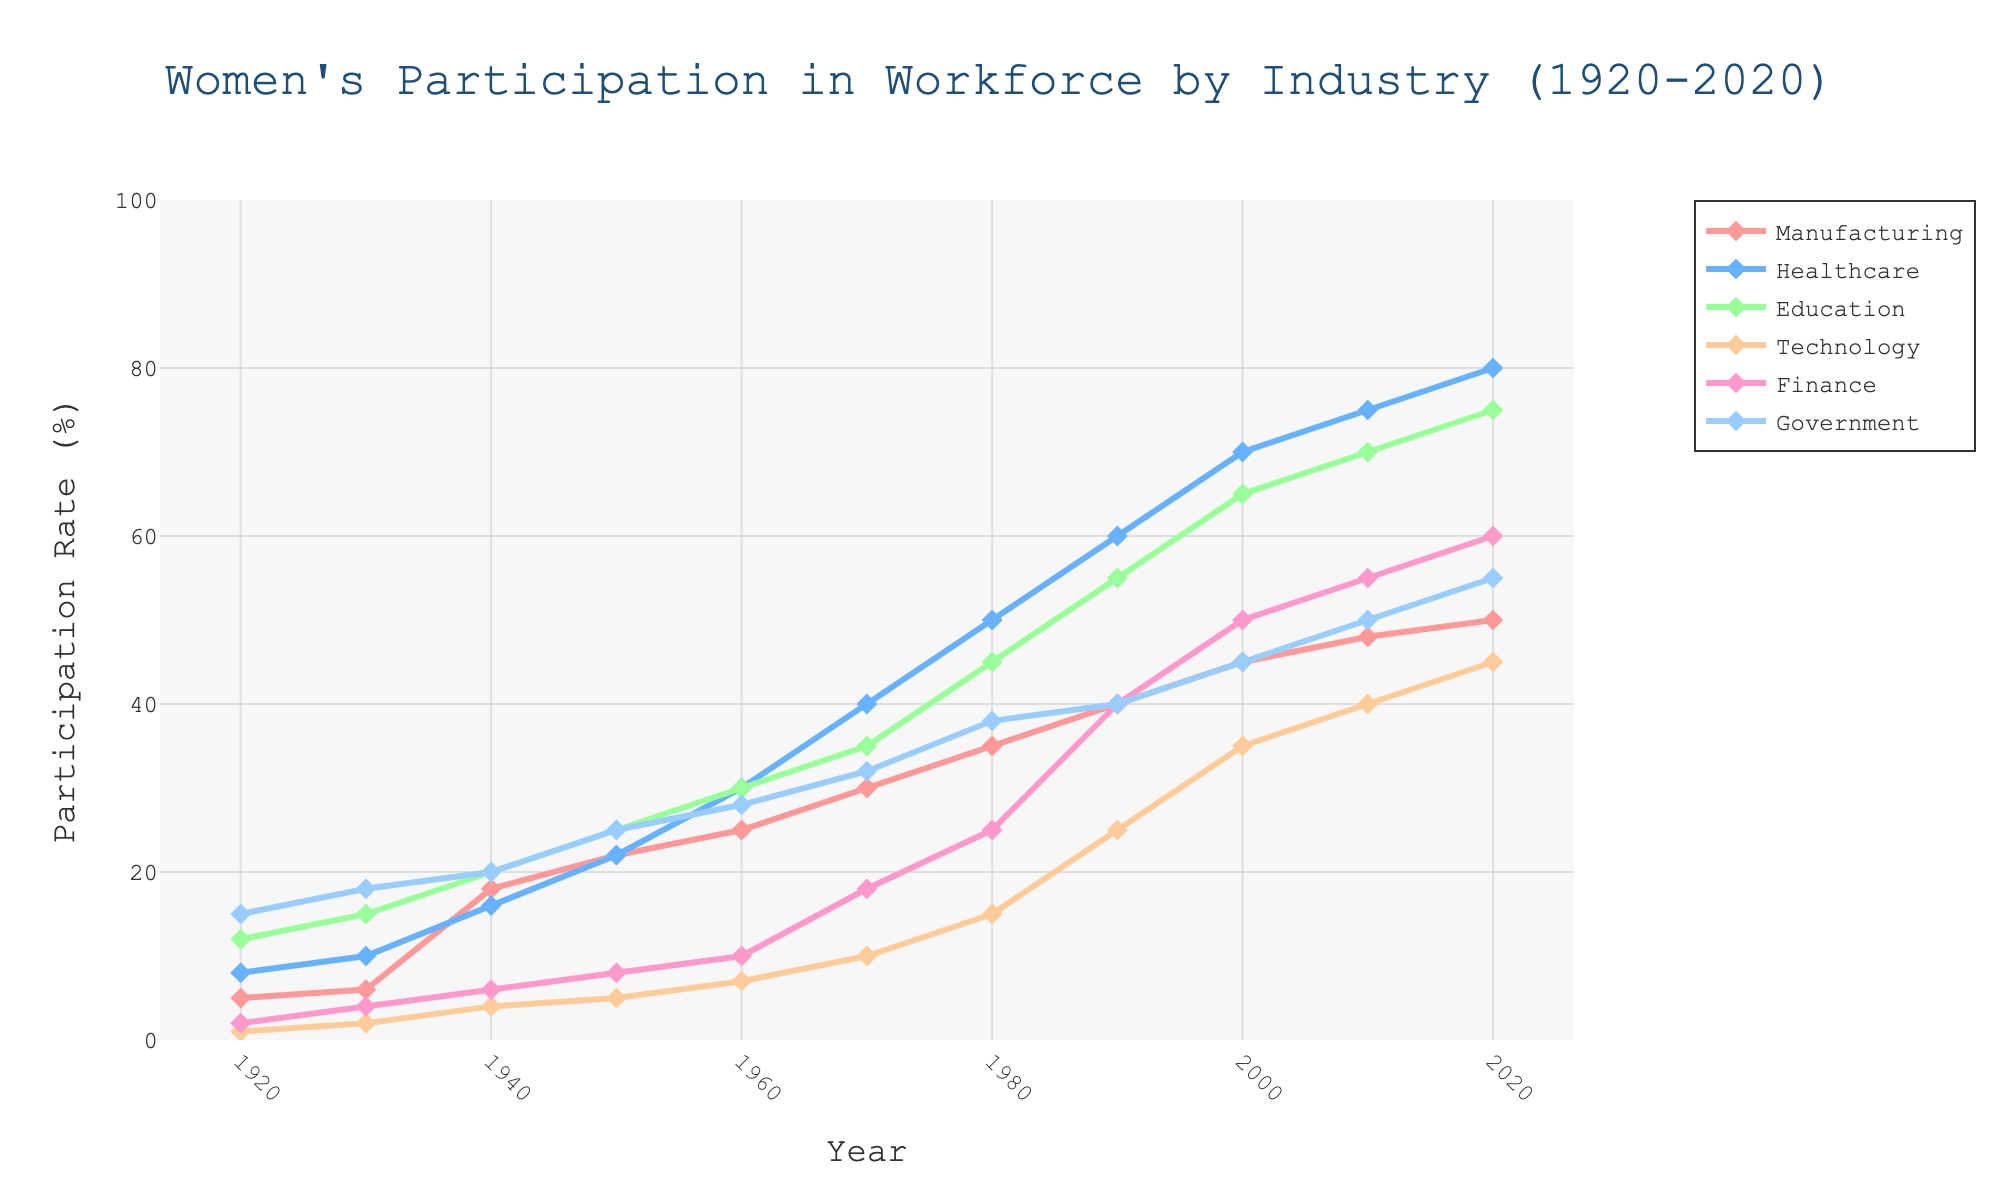What is the title of the figure? The title of the figure is displayed at the top of the plot. It reads "Women's Participation in Workforce by Industry (1920-2020)".
Answer: Women's Participation in Workforce by Industry (1920-2020) Which industry had the highest participation rate in 2020? To determine the industry with the highest participation rate in 2020, we look at the endpoints of each line in the year 2020 and identify the highest value.
Answer: Healthcare How has women's participation in Manufacturing changed from 1920 to 2020? To understand the change in Manufacturing participation over 100 years, compare the value at the start (5% in 1920) to the value at the end (50% in 2020). We can see an increase of 45 percentage points.
Answer: Increased by 45 percentage points Which two industries had similar participation rates in 1980? To find similar rates, look at the year 1980 and compare the participation rates. Both Education and Government had values close to each other (45% and 38%, respectively).
Answer: Education and Government What is the overall trend in women's participation in the Technology industry from 1920 to 2020? Observing the line for Technology, which starts at 1% in 1920 and rises to 45% in 2020, shows a clear upward trend throughout the period.
Answer: Increasing trend In which decade did women's participation in the Healthcare industry see the most significant increase? Examining the slope of the Healthcare line, the steepest incline occurs between 1960 and 1970, where participation increased by 10 percentage points (from 30% to 40%).
Answer: 1960s Compare the growth in Finance and Government participation rates from 2000 to 2020. For Finance, the rate increased from 50% in 2000 to 60% in 2020, a rise of 10 percentage points. For Government, it increased from 45% in 2000 to 55% in 2020, also a rise of 10 percentage points.
Answer: Both grew by 10 percentage points What was the participation rate for Education in 1940, and how did it compare to Manufacturing in the same year? In 1940, the participation rate for Education was at 20%, while for Manufacturing, it was at 18%. Thus, Education had a slightly higher rate.
Answer: Education: 20%, Manufacturing: 18% Which industry showed the least increase in women's participation from 1920 to 2020? By comparing the differences, Technology increased from 1% in 1920 to 45% in 2020 (44 percentage points), while other industries had larger changes.
Answer: Technology What pattern do you observe in women's participation in the Government sector over the century? Observing the Government line, we see it starts high at 15% in 1920, rises steadily to 55% by 2020, with periods of accelerated growth, especially before 1950 and after 2000.
Answer: Steady increase with significant early and late-century growth 